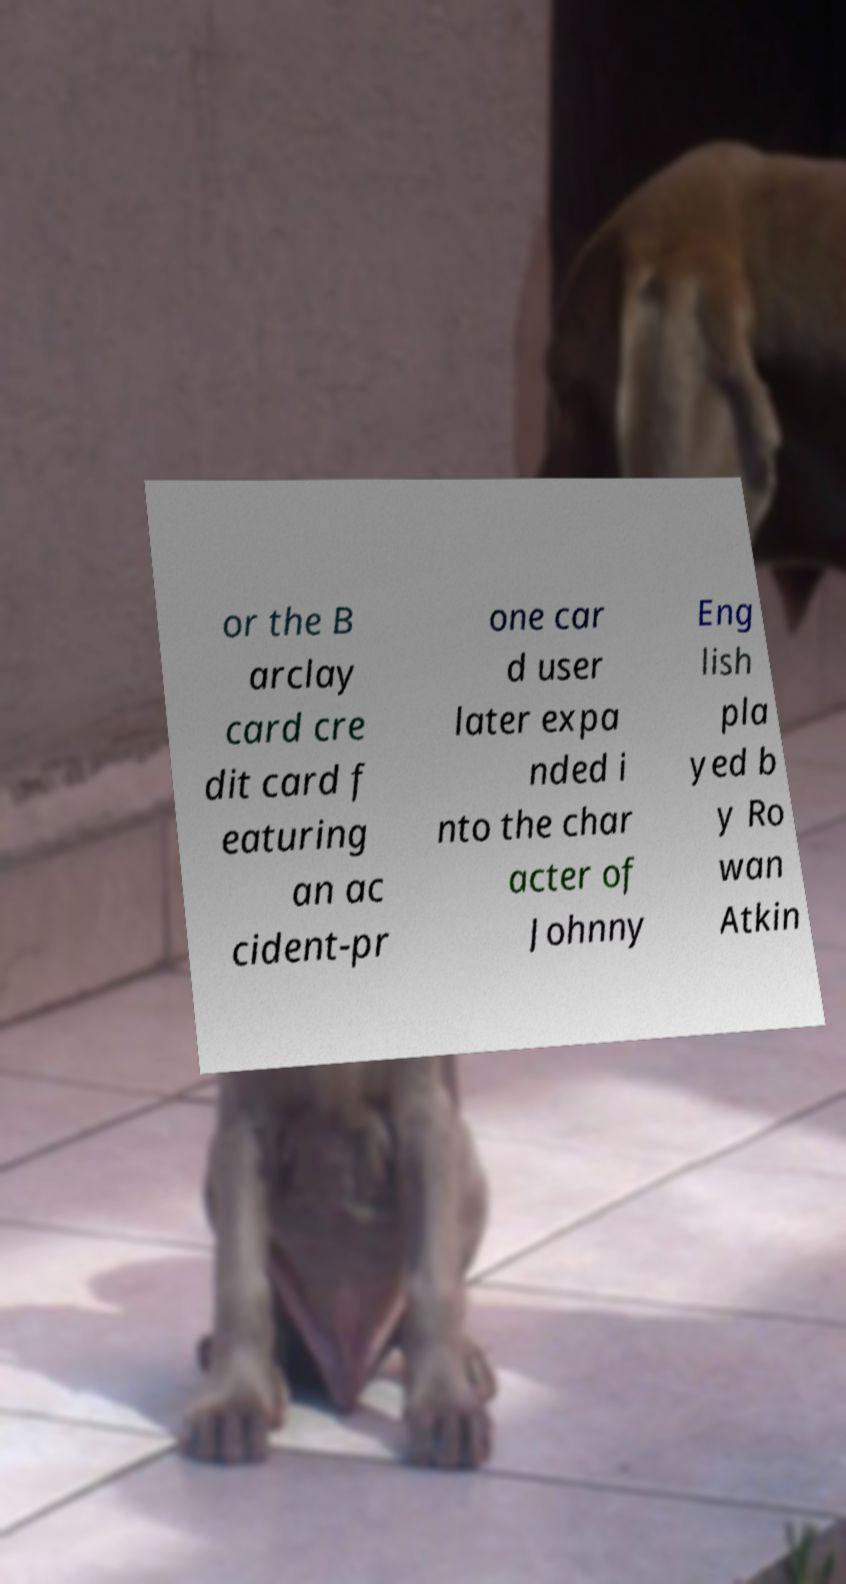There's text embedded in this image that I need extracted. Can you transcribe it verbatim? or the B arclay card cre dit card f eaturing an ac cident-pr one car d user later expa nded i nto the char acter of Johnny Eng lish pla yed b y Ro wan Atkin 